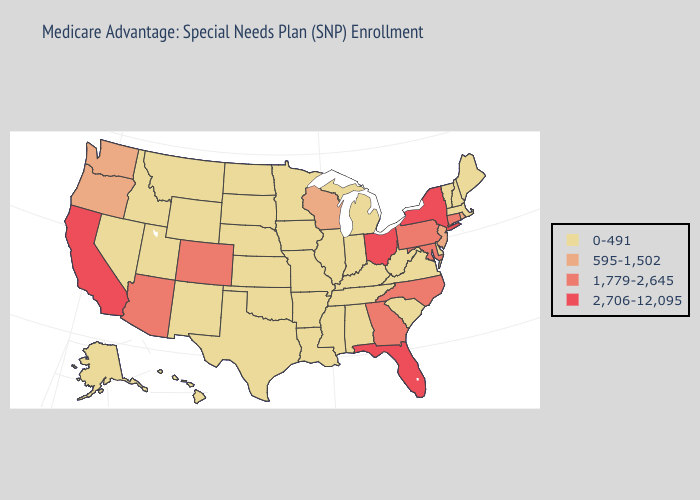What is the highest value in the West ?
Give a very brief answer. 2,706-12,095. Name the states that have a value in the range 2,706-12,095?
Write a very short answer. California, Florida, New York, Ohio. What is the lowest value in the Northeast?
Concise answer only. 0-491. Does Utah have the same value as Arizona?
Give a very brief answer. No. Does South Carolina have the highest value in the USA?
Write a very short answer. No. Does the first symbol in the legend represent the smallest category?
Keep it brief. Yes. Name the states that have a value in the range 0-491?
Quick response, please. Alaska, Alabama, Arkansas, Delaware, Hawaii, Iowa, Idaho, Illinois, Indiana, Kansas, Kentucky, Louisiana, Massachusetts, Maine, Michigan, Minnesota, Missouri, Mississippi, Montana, North Dakota, Nebraska, New Hampshire, New Mexico, Nevada, Oklahoma, South Carolina, South Dakota, Tennessee, Texas, Utah, Virginia, Vermont, West Virginia, Wyoming. Does the map have missing data?
Quick response, please. No. Does New Hampshire have the lowest value in the USA?
Write a very short answer. Yes. What is the highest value in states that border Vermont?
Give a very brief answer. 2,706-12,095. Name the states that have a value in the range 2,706-12,095?
Quick response, please. California, Florida, New York, Ohio. Does Kansas have the highest value in the MidWest?
Answer briefly. No. Name the states that have a value in the range 1,779-2,645?
Give a very brief answer. Arizona, Colorado, Connecticut, Georgia, Maryland, North Carolina, Pennsylvania. Name the states that have a value in the range 0-491?
Write a very short answer. Alaska, Alabama, Arkansas, Delaware, Hawaii, Iowa, Idaho, Illinois, Indiana, Kansas, Kentucky, Louisiana, Massachusetts, Maine, Michigan, Minnesota, Missouri, Mississippi, Montana, North Dakota, Nebraska, New Hampshire, New Mexico, Nevada, Oklahoma, South Carolina, South Dakota, Tennessee, Texas, Utah, Virginia, Vermont, West Virginia, Wyoming. Name the states that have a value in the range 595-1,502?
Give a very brief answer. New Jersey, Oregon, Rhode Island, Washington, Wisconsin. 